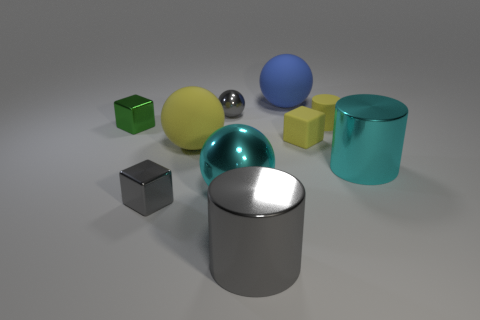Subtract 1 spheres. How many spheres are left? 3 Subtract all cubes. How many objects are left? 7 Subtract all metallic cylinders. Subtract all large yellow rubber objects. How many objects are left? 7 Add 8 gray cubes. How many gray cubes are left? 9 Add 7 small blue matte cubes. How many small blue matte cubes exist? 7 Subtract 0 blue cylinders. How many objects are left? 10 